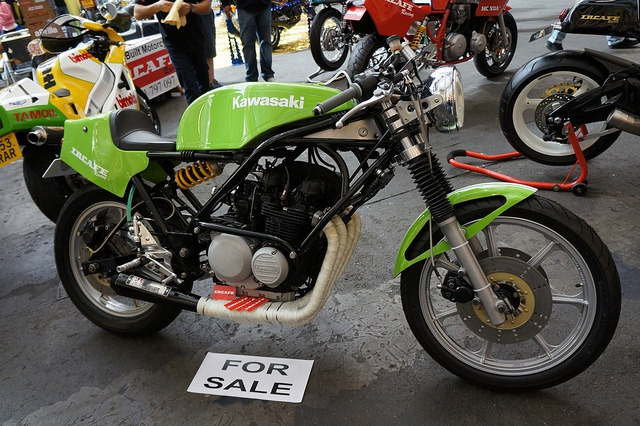Describe the objects in this image and their specific colors. I can see motorcycle in maroon, black, gray, darkgray, and olive tones, motorcycle in maroon, black, gray, and darkgray tones, motorcycle in maroon, lightgray, black, darkgray, and orange tones, motorcycle in maroon, black, and gray tones, and people in maroon, black, olive, and ivory tones in this image. 